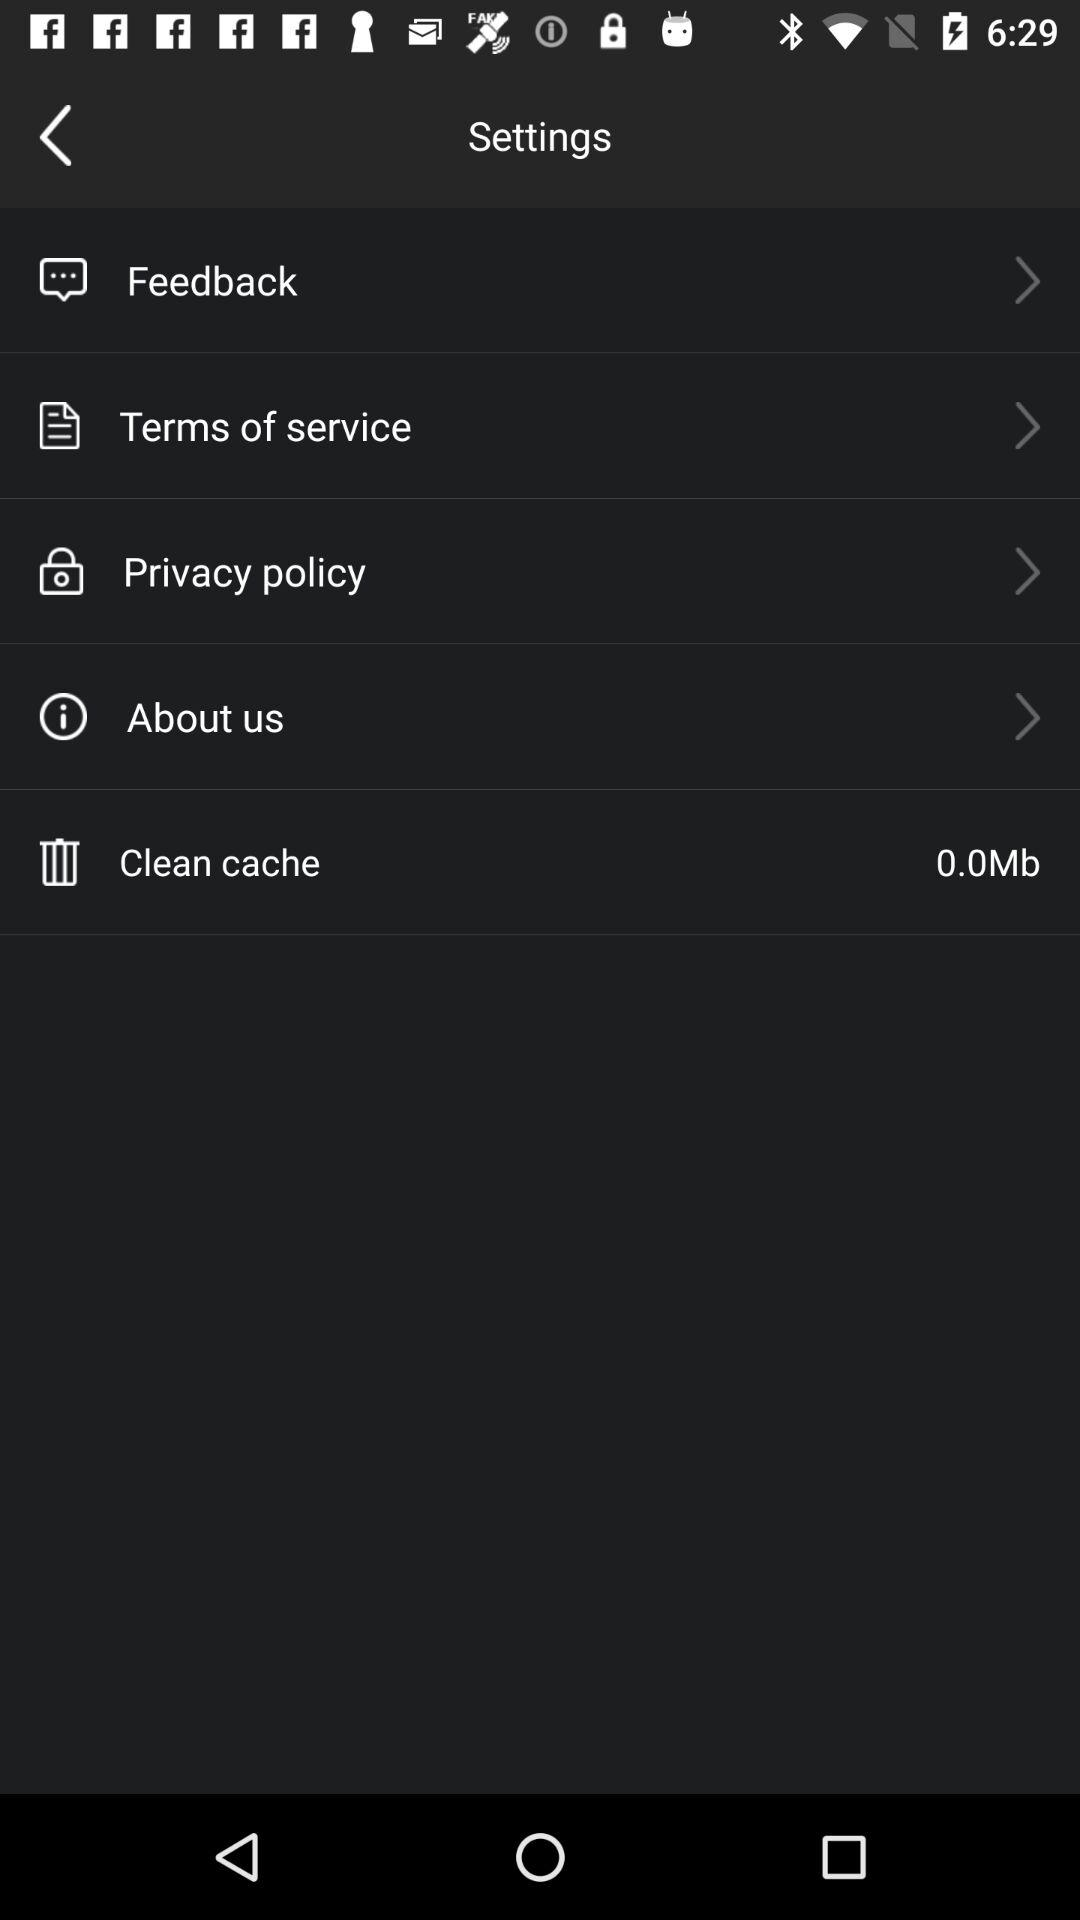How many items are in the settings menu?
Answer the question using a single word or phrase. 5 